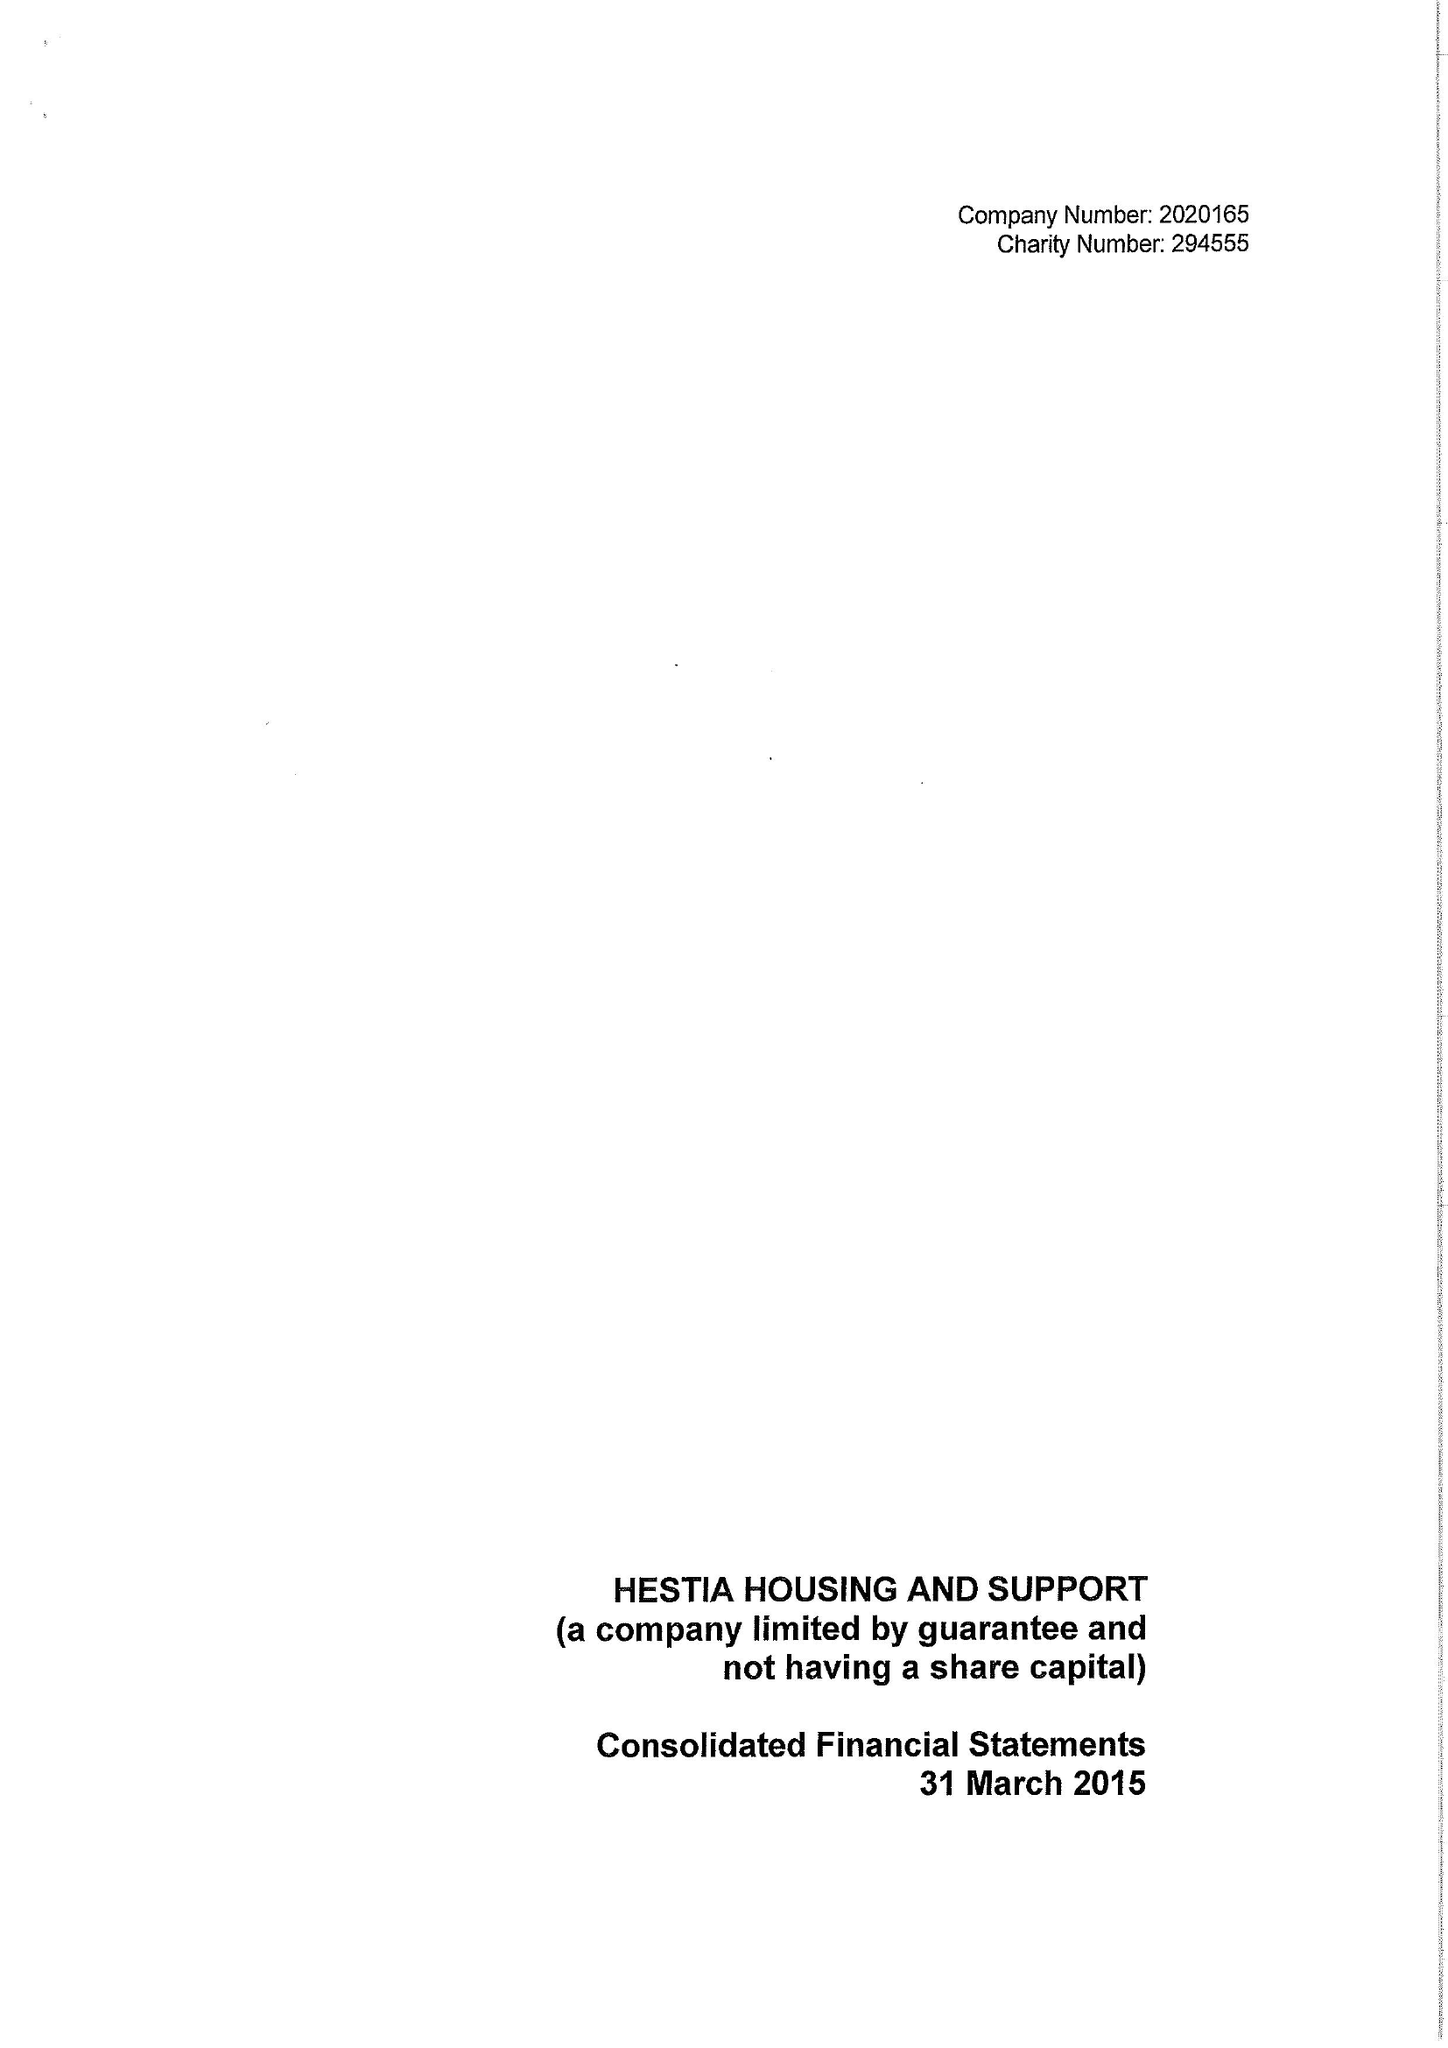What is the value for the charity_name?
Answer the question using a single word or phrase. Hestia Housing and Support 